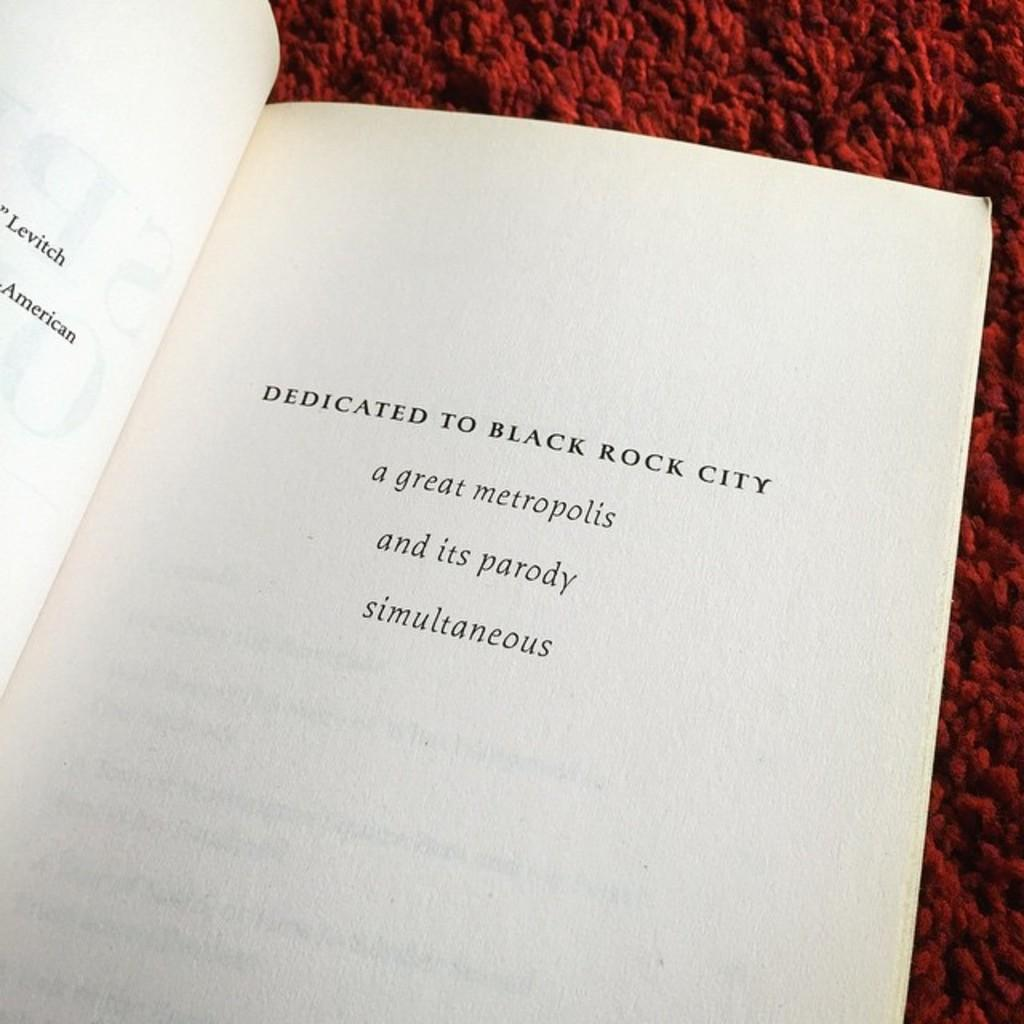<image>
Write a terse but informative summary of the picture. An open book which bears the words 'A  great metropolis' on the inside page. 